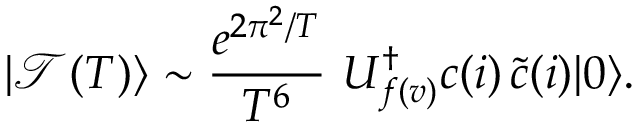Convert formula to latex. <formula><loc_0><loc_0><loc_500><loc_500>| \mathcal { T } ( T ) \rangle \sim \frac { e ^ { 2 \pi ^ { 2 } / T } } { T ^ { 6 } } \, U _ { f ( v ) } ^ { \dagger } c ( i ) \, \tilde { c } ( i ) | 0 \rangle .</formula> 